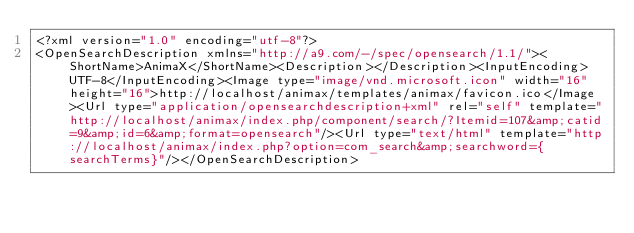<code> <loc_0><loc_0><loc_500><loc_500><_HTML_><?xml version="1.0" encoding="utf-8"?>
<OpenSearchDescription xmlns="http://a9.com/-/spec/opensearch/1.1/"><ShortName>AnimaX</ShortName><Description></Description><InputEncoding>UTF-8</InputEncoding><Image type="image/vnd.microsoft.icon" width="16" height="16">http://localhost/animax/templates/animax/favicon.ico</Image><Url type="application/opensearchdescription+xml" rel="self" template="http://localhost/animax/index.php/component/search/?Itemid=107&amp;catid=9&amp;id=6&amp;format=opensearch"/><Url type="text/html" template="http://localhost/animax/index.php?option=com_search&amp;searchword={searchTerms}"/></OpenSearchDescription>
</code> 